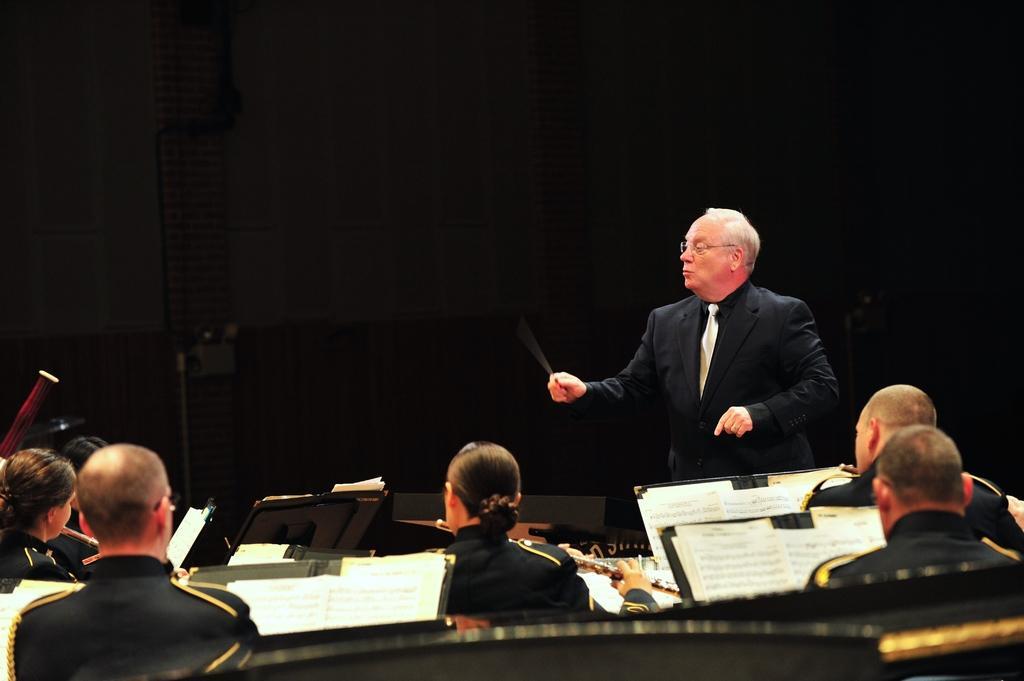Describe this image in one or two sentences. This picture shows few people seated and they are holding flutes in their hands and we see books and a man standing and holding a stick and he wore spectacles on his Face and we see a black color background. 